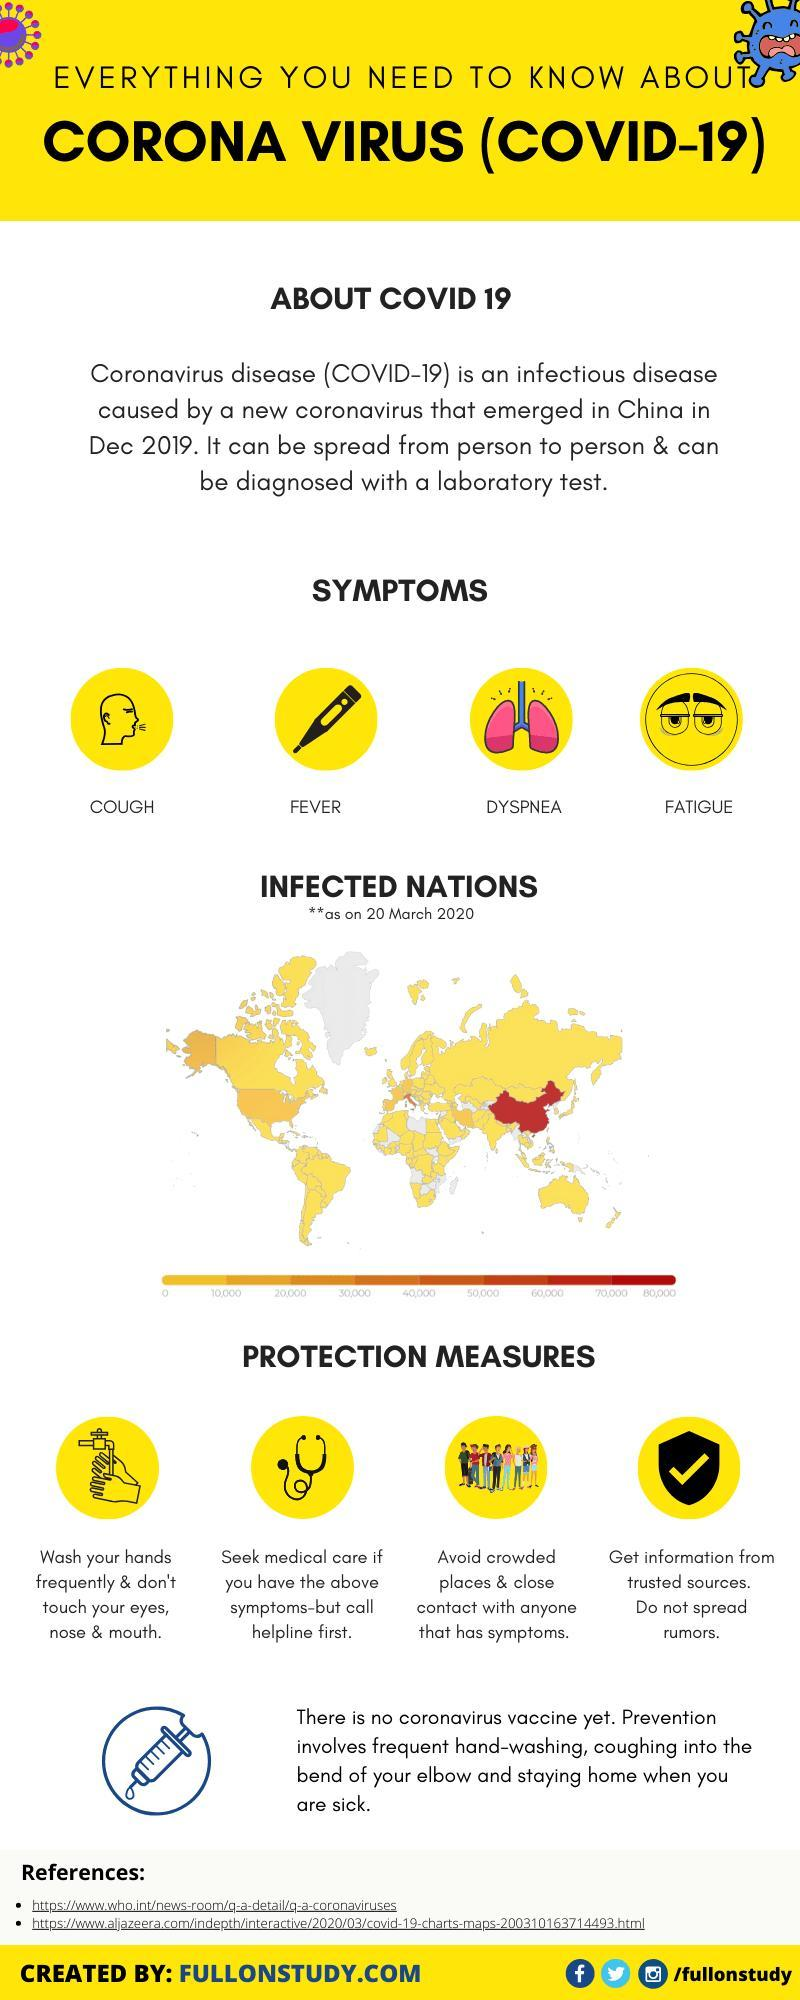What are the symptoms of COVID-19 other than cough & fatigue?
Answer the question with a short phrase. FEVER, DYSPNEA 